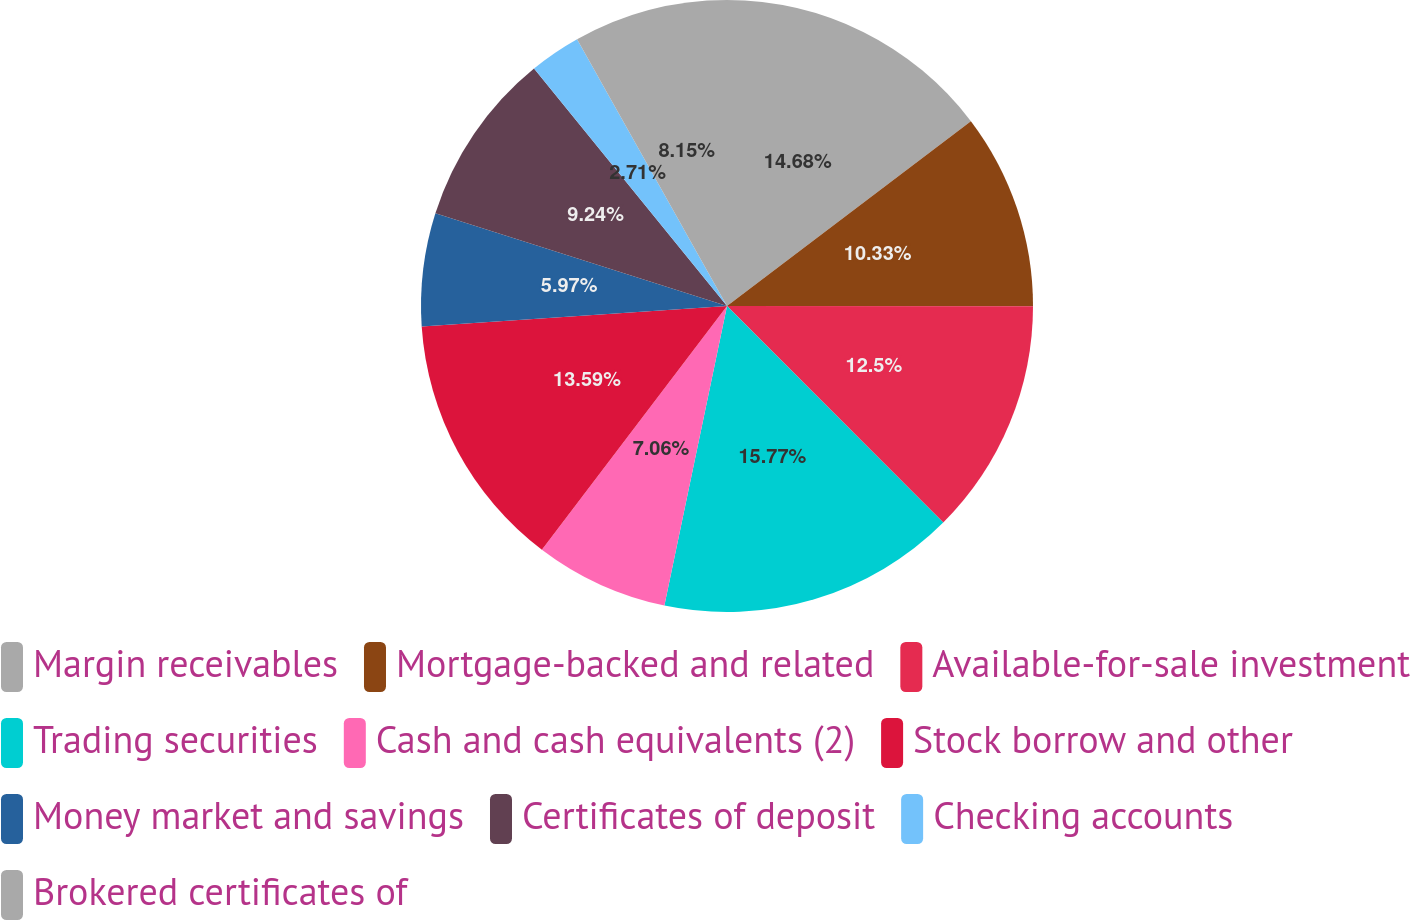Convert chart. <chart><loc_0><loc_0><loc_500><loc_500><pie_chart><fcel>Margin receivables<fcel>Mortgage-backed and related<fcel>Available-for-sale investment<fcel>Trading securities<fcel>Cash and cash equivalents (2)<fcel>Stock borrow and other<fcel>Money market and savings<fcel>Certificates of deposit<fcel>Checking accounts<fcel>Brokered certificates of<nl><fcel>14.68%<fcel>10.33%<fcel>12.5%<fcel>15.77%<fcel>7.06%<fcel>13.59%<fcel>5.97%<fcel>9.24%<fcel>2.71%<fcel>8.15%<nl></chart> 